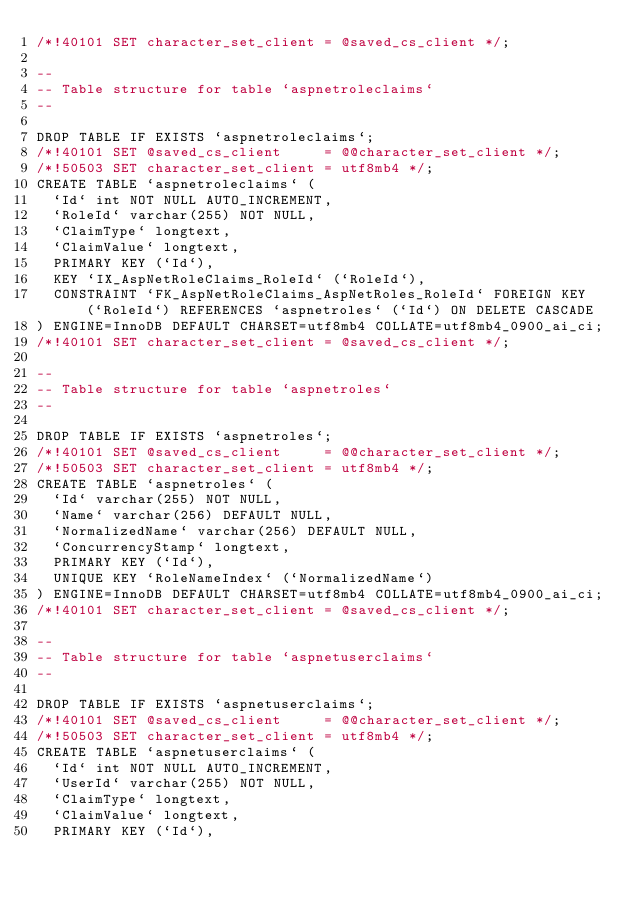Convert code to text. <code><loc_0><loc_0><loc_500><loc_500><_SQL_>/*!40101 SET character_set_client = @saved_cs_client */;

--
-- Table structure for table `aspnetroleclaims`
--

DROP TABLE IF EXISTS `aspnetroleclaims`;
/*!40101 SET @saved_cs_client     = @@character_set_client */;
/*!50503 SET character_set_client = utf8mb4 */;
CREATE TABLE `aspnetroleclaims` (
  `Id` int NOT NULL AUTO_INCREMENT,
  `RoleId` varchar(255) NOT NULL,
  `ClaimType` longtext,
  `ClaimValue` longtext,
  PRIMARY KEY (`Id`),
  KEY `IX_AspNetRoleClaims_RoleId` (`RoleId`),
  CONSTRAINT `FK_AspNetRoleClaims_AspNetRoles_RoleId` FOREIGN KEY (`RoleId`) REFERENCES `aspnetroles` (`Id`) ON DELETE CASCADE
) ENGINE=InnoDB DEFAULT CHARSET=utf8mb4 COLLATE=utf8mb4_0900_ai_ci;
/*!40101 SET character_set_client = @saved_cs_client */;

--
-- Table structure for table `aspnetroles`
--

DROP TABLE IF EXISTS `aspnetroles`;
/*!40101 SET @saved_cs_client     = @@character_set_client */;
/*!50503 SET character_set_client = utf8mb4 */;
CREATE TABLE `aspnetroles` (
  `Id` varchar(255) NOT NULL,
  `Name` varchar(256) DEFAULT NULL,
  `NormalizedName` varchar(256) DEFAULT NULL,
  `ConcurrencyStamp` longtext,
  PRIMARY KEY (`Id`),
  UNIQUE KEY `RoleNameIndex` (`NormalizedName`)
) ENGINE=InnoDB DEFAULT CHARSET=utf8mb4 COLLATE=utf8mb4_0900_ai_ci;
/*!40101 SET character_set_client = @saved_cs_client */;

--
-- Table structure for table `aspnetuserclaims`
--

DROP TABLE IF EXISTS `aspnetuserclaims`;
/*!40101 SET @saved_cs_client     = @@character_set_client */;
/*!50503 SET character_set_client = utf8mb4 */;
CREATE TABLE `aspnetuserclaims` (
  `Id` int NOT NULL AUTO_INCREMENT,
  `UserId` varchar(255) NOT NULL,
  `ClaimType` longtext,
  `ClaimValue` longtext,
  PRIMARY KEY (`Id`),</code> 